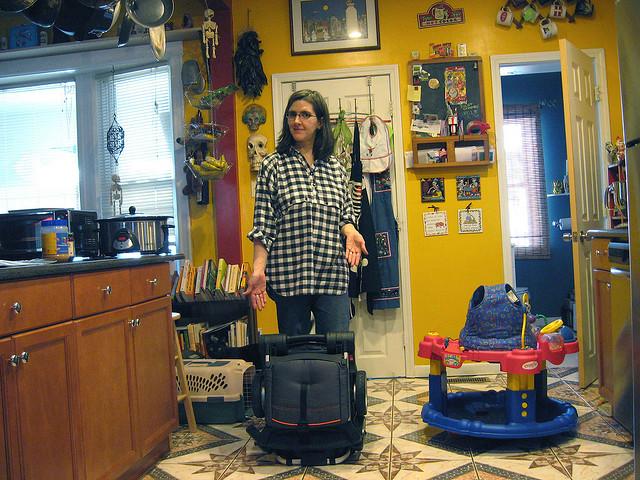Does this family have young children?
Short answer required. Yes. What type of dishes are hanging above the door?
Keep it brief. Mugs. Are both doors open?
Write a very short answer. No. 